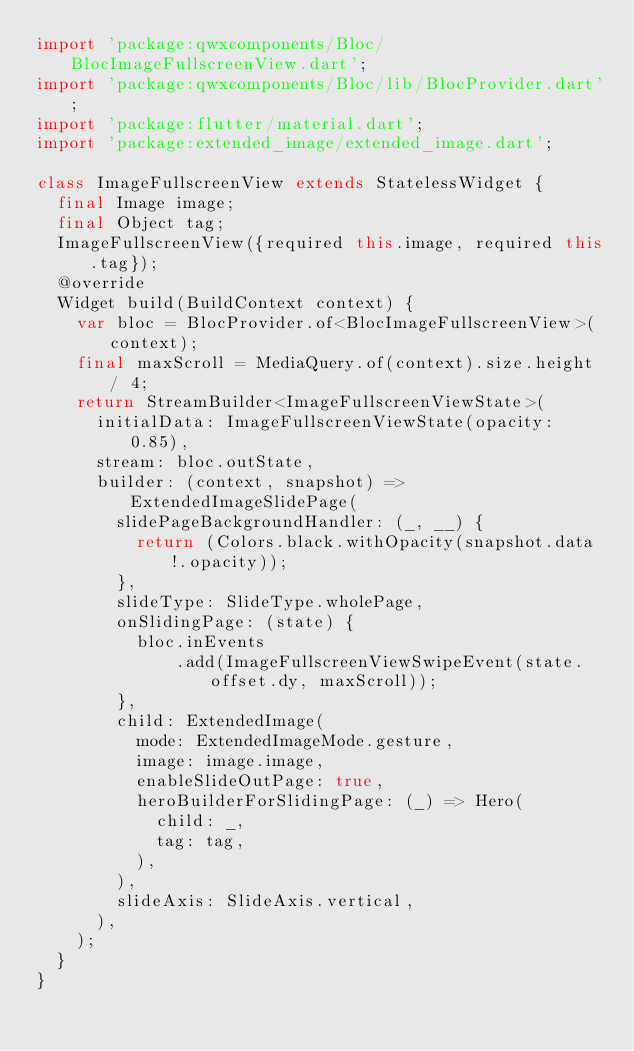<code> <loc_0><loc_0><loc_500><loc_500><_Dart_>import 'package:qwxcomponents/Bloc/BlocImageFullscreenView.dart';
import 'package:qwxcomponents/Bloc/lib/BlocProvider.dart';
import 'package:flutter/material.dart';
import 'package:extended_image/extended_image.dart';

class ImageFullscreenView extends StatelessWidget {
  final Image image;
  final Object tag;
  ImageFullscreenView({required this.image, required this.tag});
  @override
  Widget build(BuildContext context) {
    var bloc = BlocProvider.of<BlocImageFullscreenView>(context);
    final maxScroll = MediaQuery.of(context).size.height / 4;
    return StreamBuilder<ImageFullscreenViewState>(
      initialData: ImageFullscreenViewState(opacity: 0.85),
      stream: bloc.outState,
      builder: (context, snapshot) => ExtendedImageSlidePage(
        slidePageBackgroundHandler: (_, __) {
          return (Colors.black.withOpacity(snapshot.data!.opacity));
        },
        slideType: SlideType.wholePage,
        onSlidingPage: (state) {
          bloc.inEvents
              .add(ImageFullscreenViewSwipeEvent(state.offset.dy, maxScroll));
        },
        child: ExtendedImage(
          mode: ExtendedImageMode.gesture,
          image: image.image,
          enableSlideOutPage: true,
          heroBuilderForSlidingPage: (_) => Hero(
            child: _,
            tag: tag,
          ),
        ),
        slideAxis: SlideAxis.vertical,
      ),
    );
  }
}
</code> 